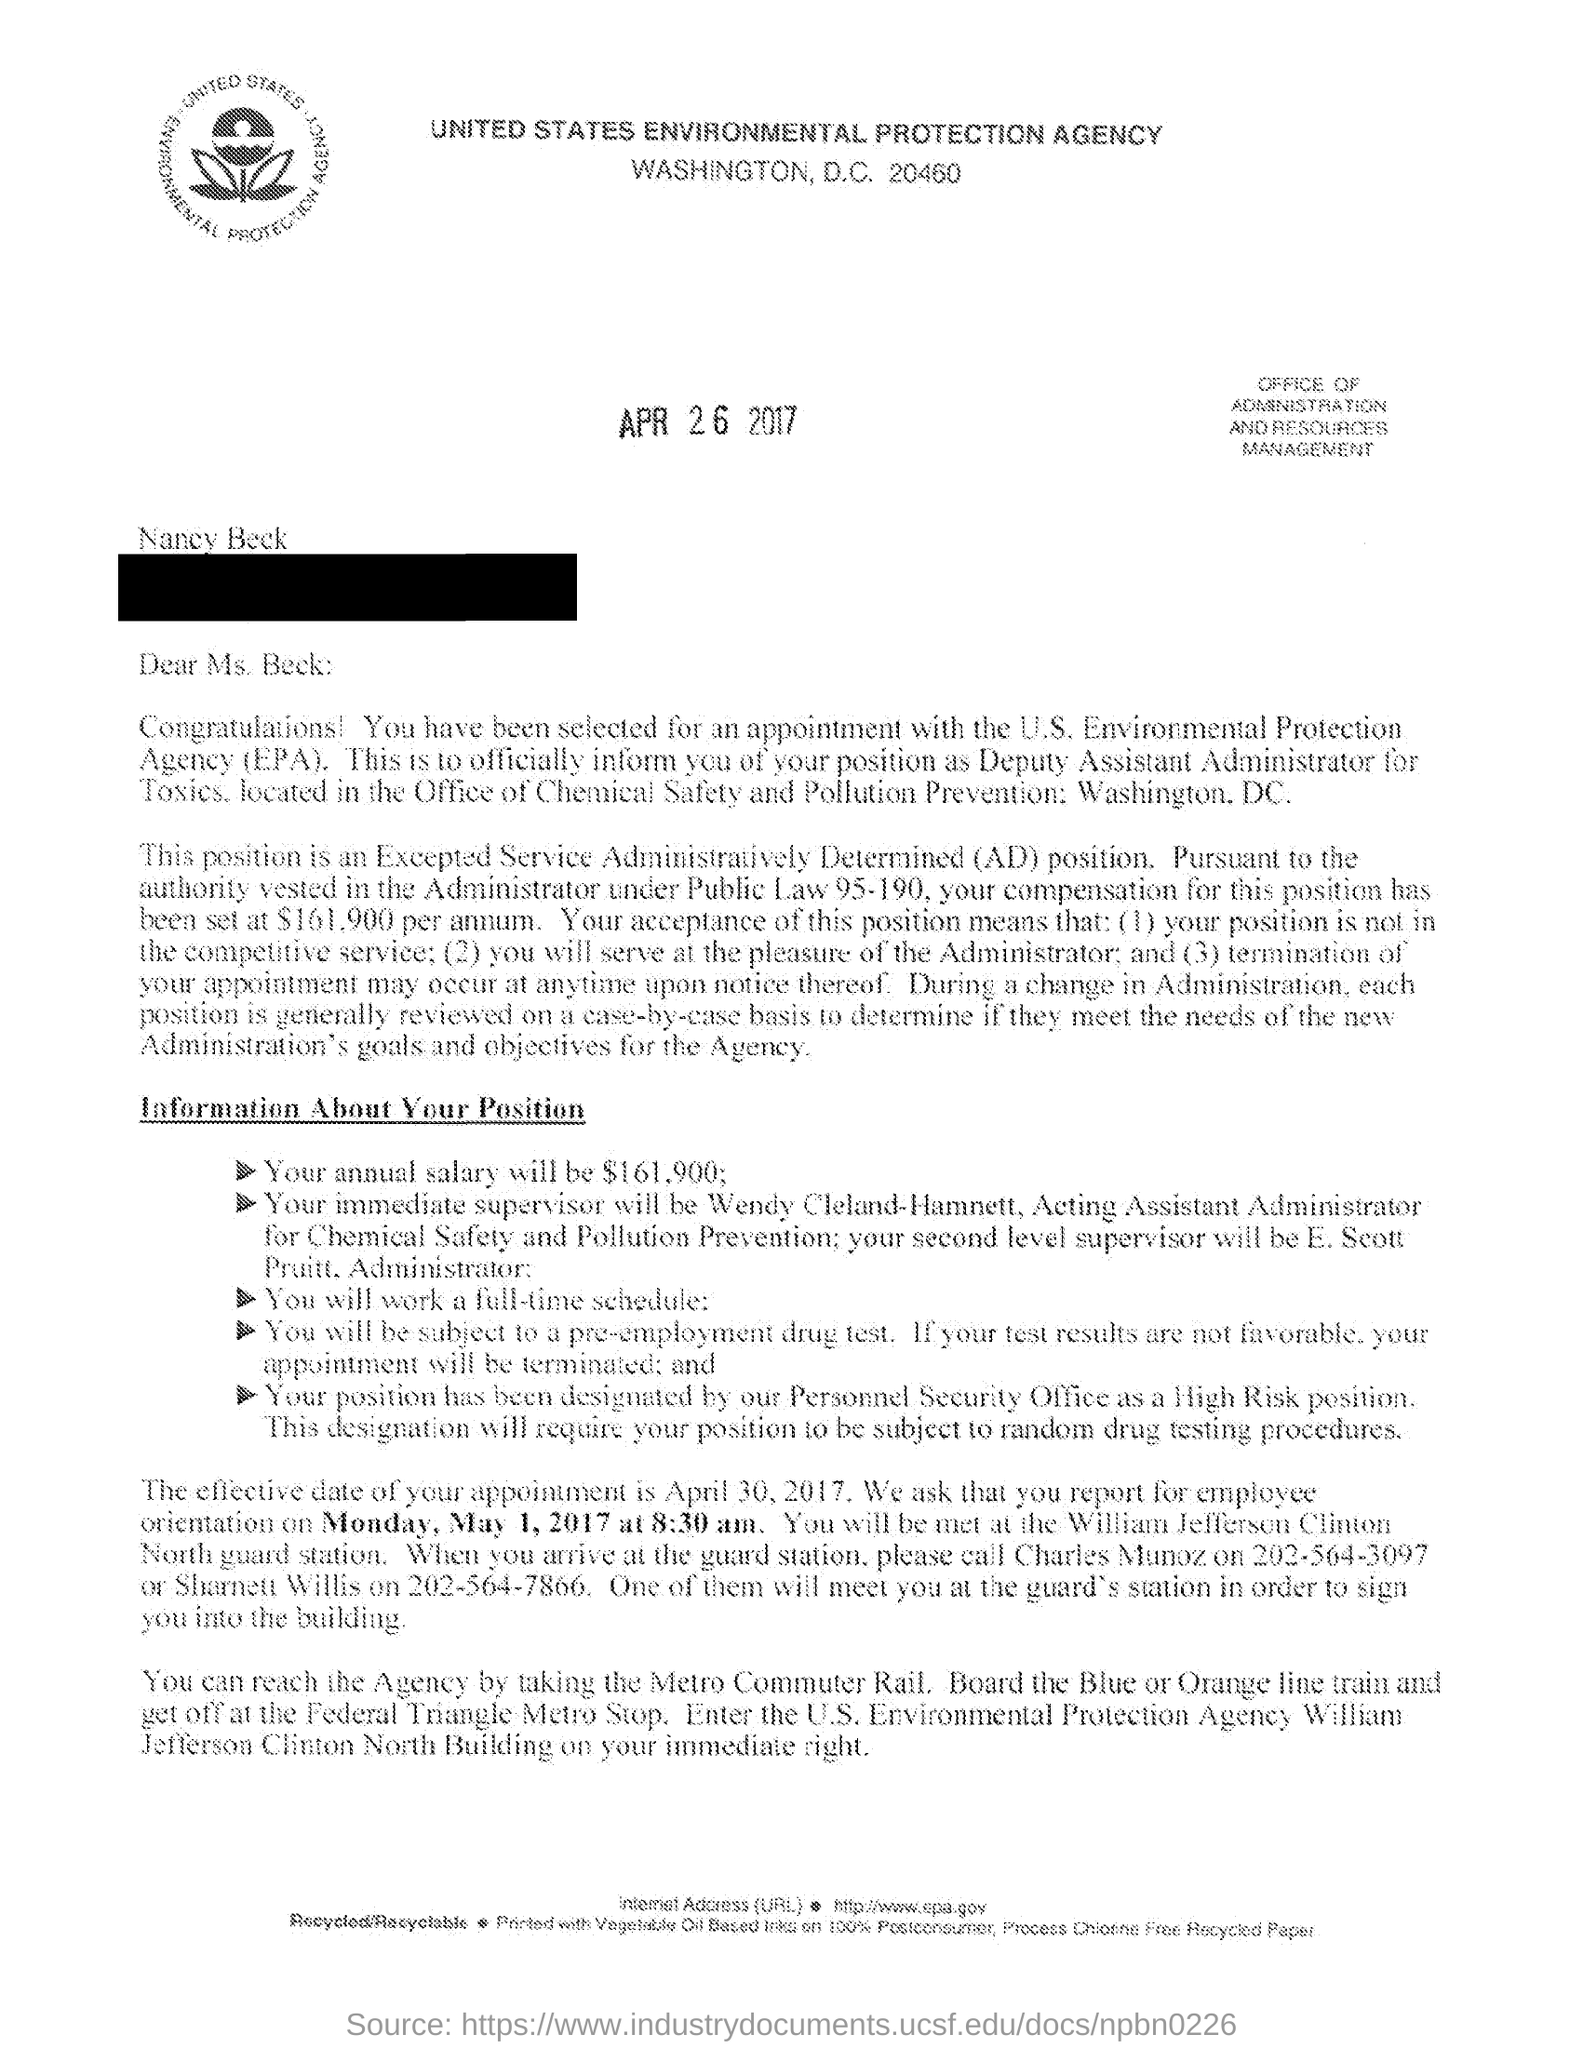Who is selected for an appointment in this letter?
Provide a succinct answer. Nancy beck. What does epa stands for ?
Your answer should be very brief. Environmental protection agency. At what time does the orientation start on Monday, May 1, 2017?
Make the answer very short. 8:30 am. Mention the compensation for beck's AD position has been set per annum
Your response must be concise. $161,900. What is the effective date of beck's appointment?
Make the answer very short. April 30,2017. 